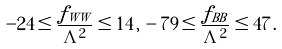<formula> <loc_0><loc_0><loc_500><loc_500>- 2 4 \leq \frac { f _ { W W } } { \Lambda ^ { 2 } } \leq 1 4 \, , \, - 7 9 \leq \frac { f _ { B B } } { \Lambda ^ { 2 } } \leq 4 7 \, .</formula> 